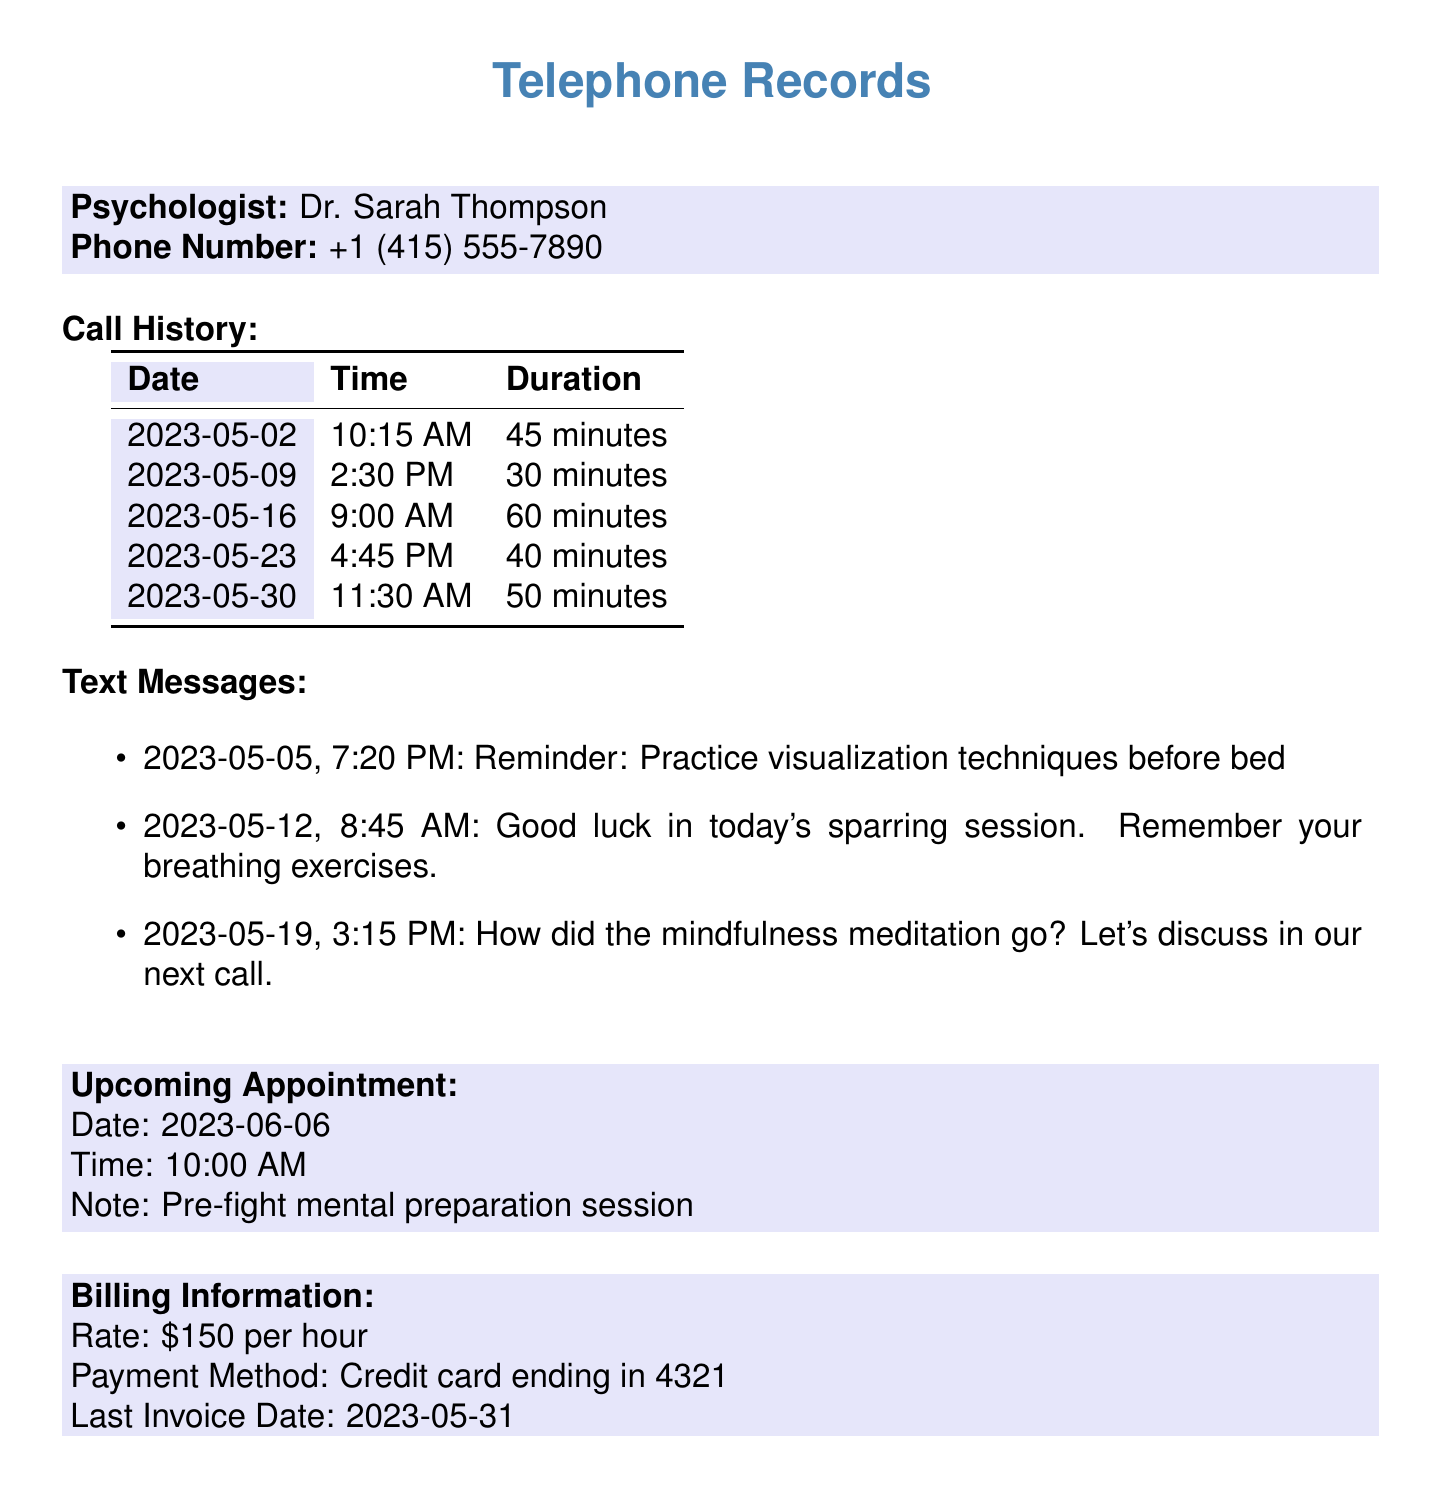What is the name of the psychologist? The psychologist's name is mentioned at the beginning of the document.
Answer: Dr. Sarah Thompson What is the phone number of the psychologist? The phone number is listed right after the psychologist's name.
Answer: +1 (415) 555-7890 What is the duration of the call on May 16? The duration for the call on this date is specified in the call history table.
Answer: 60 minutes How many text messages are listed in the document? The number of text messages is the total count shown in the text message section.
Answer: 3 What is the date and time of the upcoming appointment? This information is detailed in the upcoming appointment section.
Answer: 2023-06-06, 10:00 AM What was the purpose of the upcoming appointment? The purpose is clearly stated in the notes under the upcoming appointment section.
Answer: Pre-fight mental preparation session How many minutes was the shortest call? The duration of the calls can be compared to find the shortest one.
Answer: 30 minutes What is the billing rate for the psychologist? The billing information section provides the rate charged by the psychologist.
Answer: $150 per hour What reminder was sent on May 5? The specific reminder message is listed under the text message section.
Answer: Practice visualization techniques before bed 